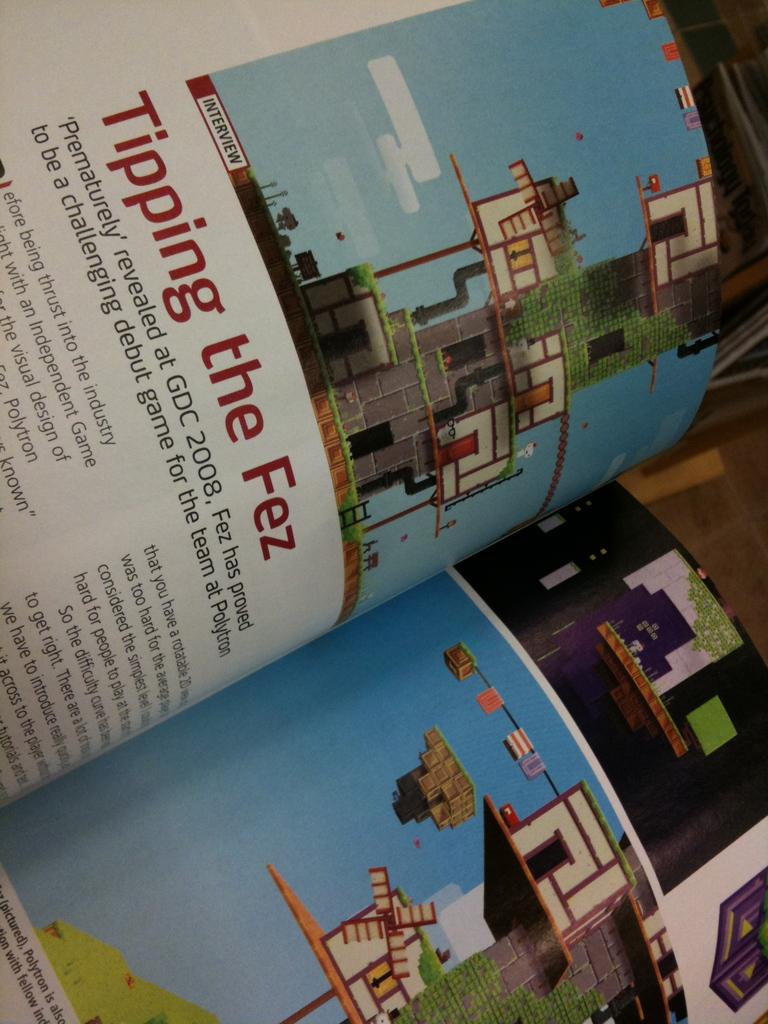<image>
Relay a brief, clear account of the picture shown. A book about gaming is open to a page that says, "Tipping the Fez". 